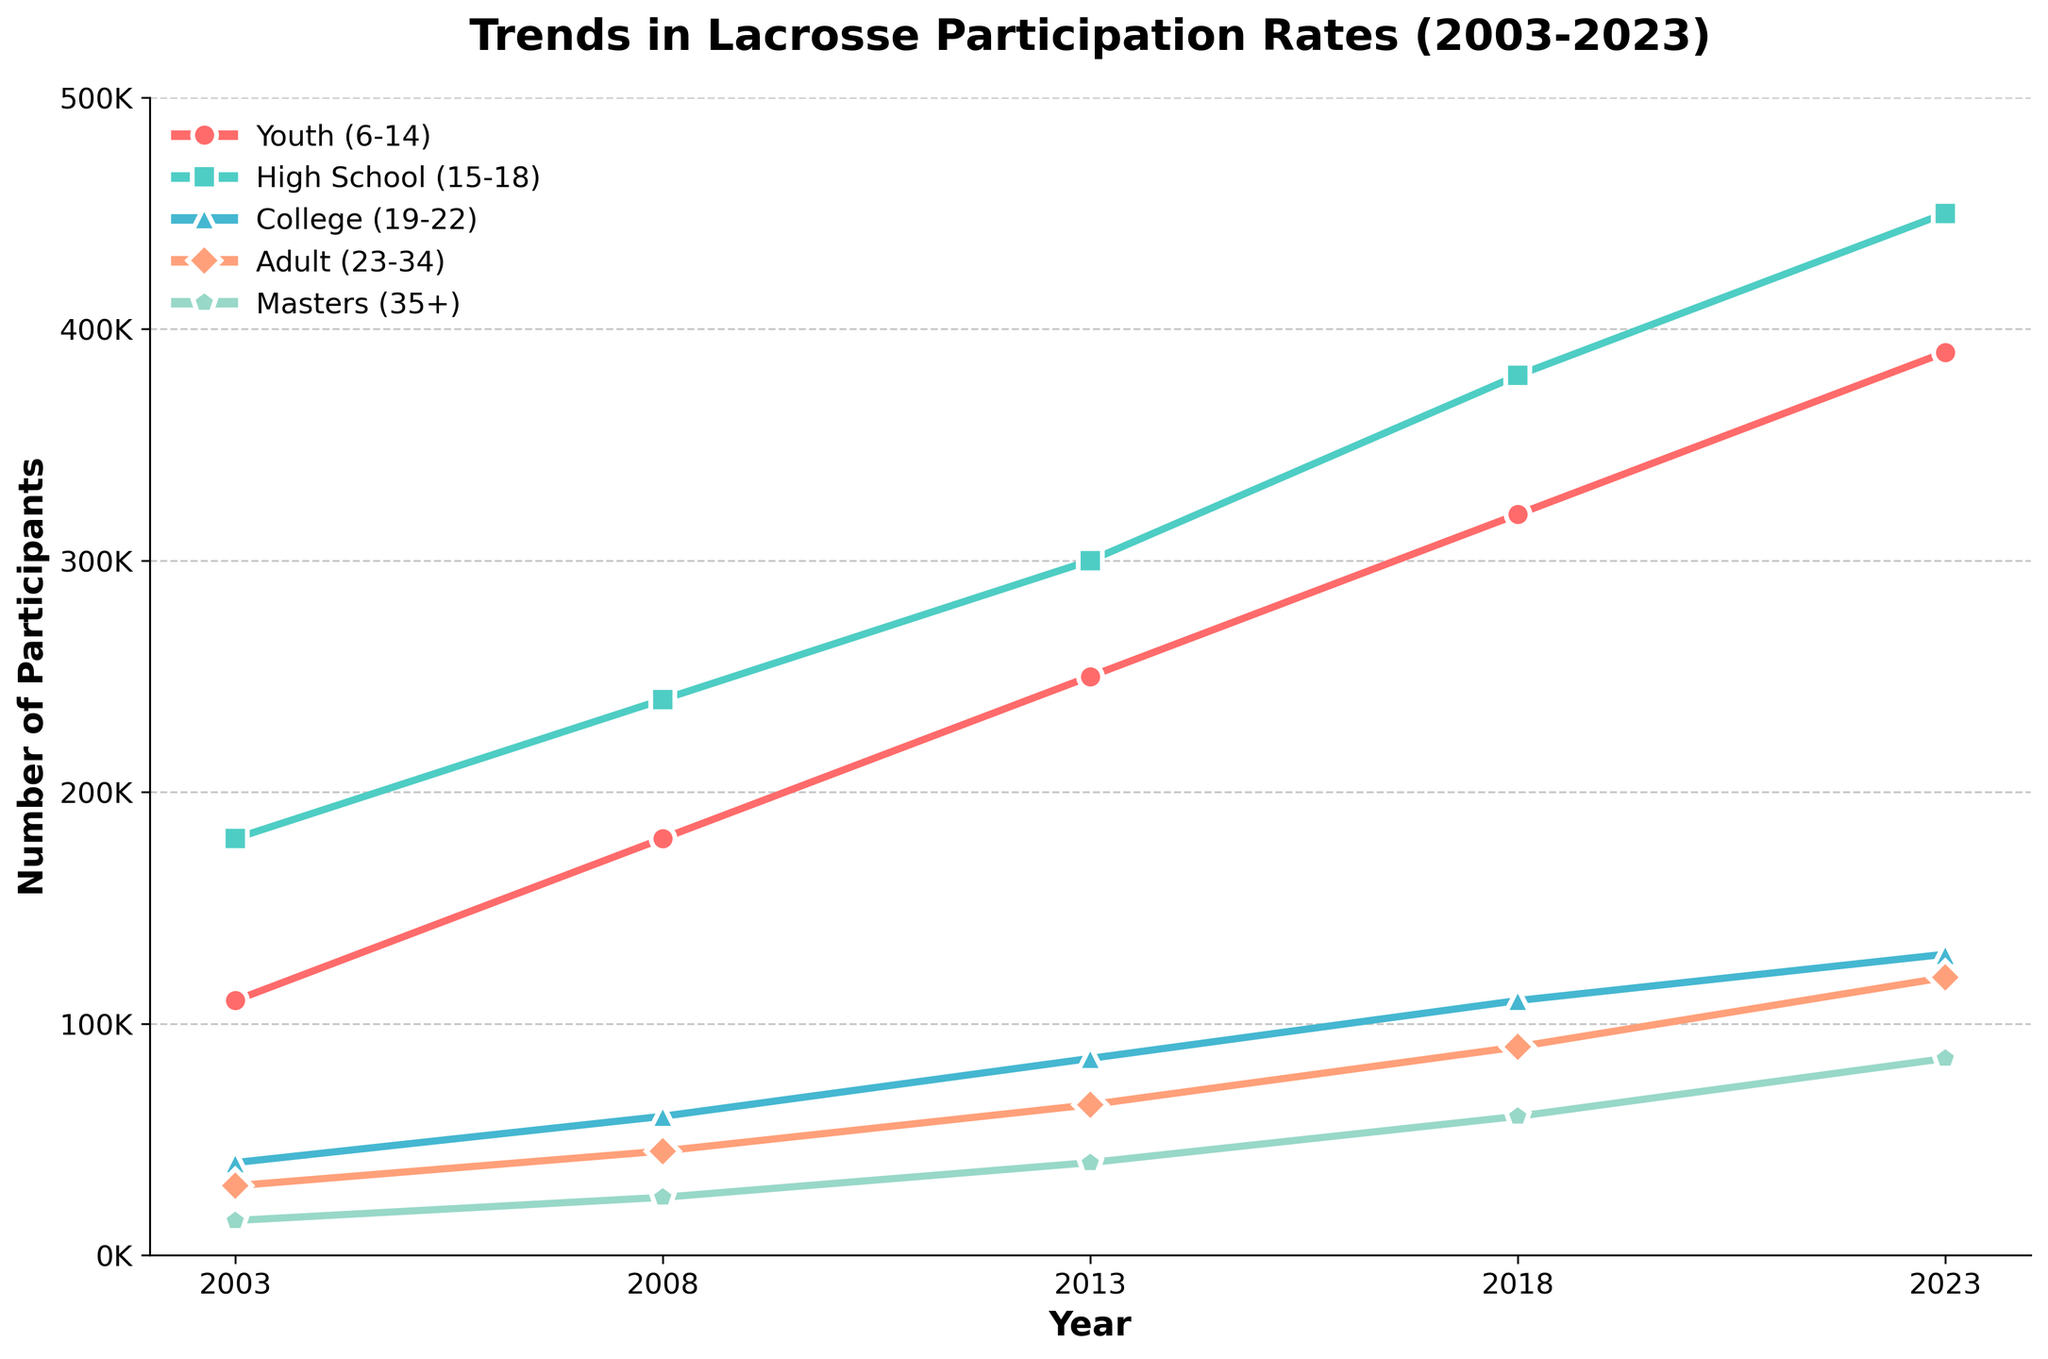What is the trend in lacrosse participation for Youth (6-14) from 2003 to 2023? The chart shows a consistent increase in participation for Youth (6-14) from around 110,000 in 2003 to approximately 390,000 in 2023. Observing the red line with circles, it's clear the trend is upward.
Answer: Increasing Which age group had the highest participation in 2013? In 2013, the green line with squares representing High School (15-18) is highest on the chart, indicating it had the most participants, about 300,000.
Answer: High School (15-18) How did the number of participants in College (19-22) change from 2003 to 2023? The chart shows an increase for College (19-22) from around 40,000 in 2003 to about 130,000 in 2023. This can be identified by the blue line with triangles.
Answer: Increased Looking at 2023, how do participation rates in Masters (35+) compare to those in College (19-22)? In 2023, the pink pentagon line representing Masters (35+) reaches 85,000, while the blue triangle line for College (19-22) reaches 130,000. Hence, participation in College is greater.
Answer: College (19-22) has higher participation Which age group experienced the greatest increase in participants between 2003 and 2023? By comparing the difference between 2023 and 2003 for each age group, Youth (6-14) appears to have the greatest growth, increasing by 280,000 (from 110,000 to 390,000).
Answer: Youth (6-14) Among all age groups, which one had the lowest participation rate in 2003? The chart shows that the purple line with diamonds for Masters (35+) starts at about 15,000 in 2003, which is the lowest among all age groups.
Answer: Masters (35+) In what year did the Adult (23-34) age group surpass 60,000 participants? Observing the orange line with diamonds, the Adult (23-34) group surpasses 60,000 participants between 2013 and 2018. Specifically, the value for 2018 is 90,000.
Answer: 2018 Calculate the average participation rate for High School (15-18) between 2003 and 2023. The High School (15-18) rates are 180,000, 240,000, 300,000, 380,000, and 450,000. Sum them: 180,000 + 240,000 + 300,000 + 380,000 + 450,000 = 1,550,000. Average = 1,550,000 / 5 = 310,000.
Answer: 310,000 What color represents the Youth (6-14) age group in the chart? The chart uses a red line with circles to represent the Youth (6-14) age group.
Answer: Red 